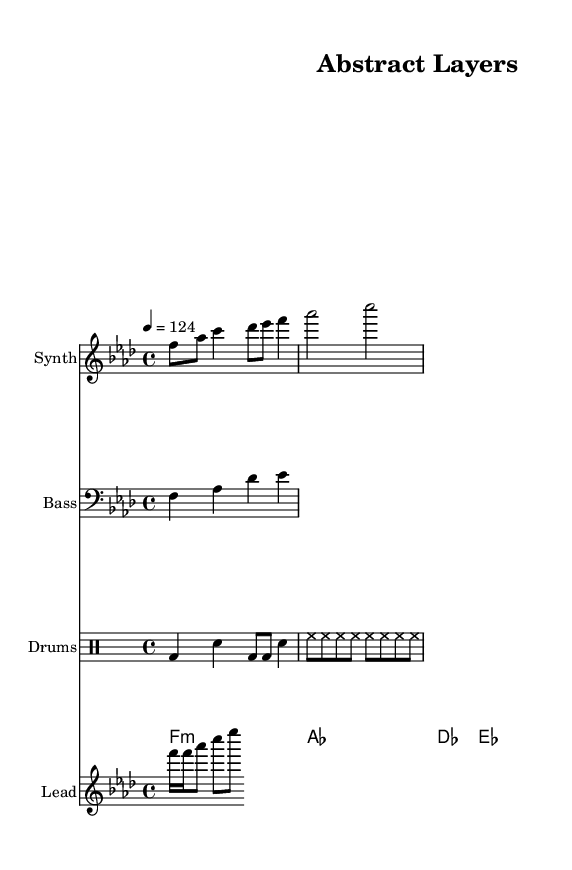What is the key signature of this music? The key signature is F minor, which has four flats: B♭, E♭, A♭, and D♭. This can be determined by looking at the key signature at the beginning of the sheet music.
Answer: F minor What is the time signature of this music? The time signature displayed at the beginning of the sheet music is 4/4, indicating that there are four beats per measure and the quarter note gets one beat.
Answer: 4/4 What is the tempo marking for this music? The tempo marking is 4 equals 124, which tells us that there are 124 beats per minute, and the quarter note receives one beat. This is typically found above the staff.
Answer: 124 How many measures are in the melody line shown? There are 8 measures in the melody line, which can be counted by observing the number of bar lines that divide the music into sections.
Answer: 8 What type of chord progression is used in the pad chords? The chord progression used is F minor, A♭ major, D♭ major, and E♭ major, which suggests a common deep house harmonic structure. This is identified by the chords listed in the chord names section.
Answer: Minor and major chords Which instrument plays the bass line? The bass line is played by the instrument labeled "Bass," which is indicated by the staff marker at the beginning of that line within the sheet music.
Answer: Bass What rhythmic elements are present in the drum part? The drum part features a combination of bass drums, snare hits, and hi-hats, denoted by the specific drum notation found within the drum staff section of the score.
Answer: Bass drum, snare, hi-hat 